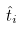Convert formula to latex. <formula><loc_0><loc_0><loc_500><loc_500>\hat { t } _ { i }</formula> 